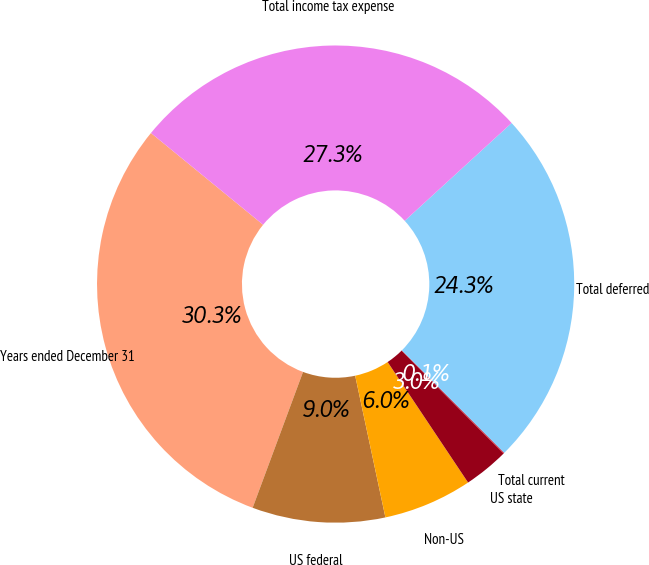<chart> <loc_0><loc_0><loc_500><loc_500><pie_chart><fcel>Years ended December 31<fcel>US federal<fcel>Non-US<fcel>US state<fcel>Total current<fcel>Total deferred<fcel>Total income tax expense<nl><fcel>30.26%<fcel>9.0%<fcel>6.02%<fcel>3.05%<fcel>0.07%<fcel>24.31%<fcel>27.29%<nl></chart> 